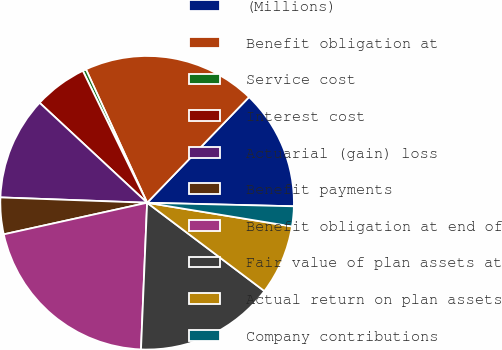Convert chart. <chart><loc_0><loc_0><loc_500><loc_500><pie_chart><fcel>(Millions)<fcel>Benefit obligation at<fcel>Service cost<fcel>Interest cost<fcel>Actuarial (gain) loss<fcel>Benefit payments<fcel>Benefit obligation at end of<fcel>Fair value of plan assets at<fcel>Actual return on plan assets<fcel>Company contributions<nl><fcel>13.17%<fcel>19.05%<fcel>0.38%<fcel>5.86%<fcel>11.34%<fcel>4.03%<fcel>20.88%<fcel>15.39%<fcel>7.69%<fcel>2.2%<nl></chart> 